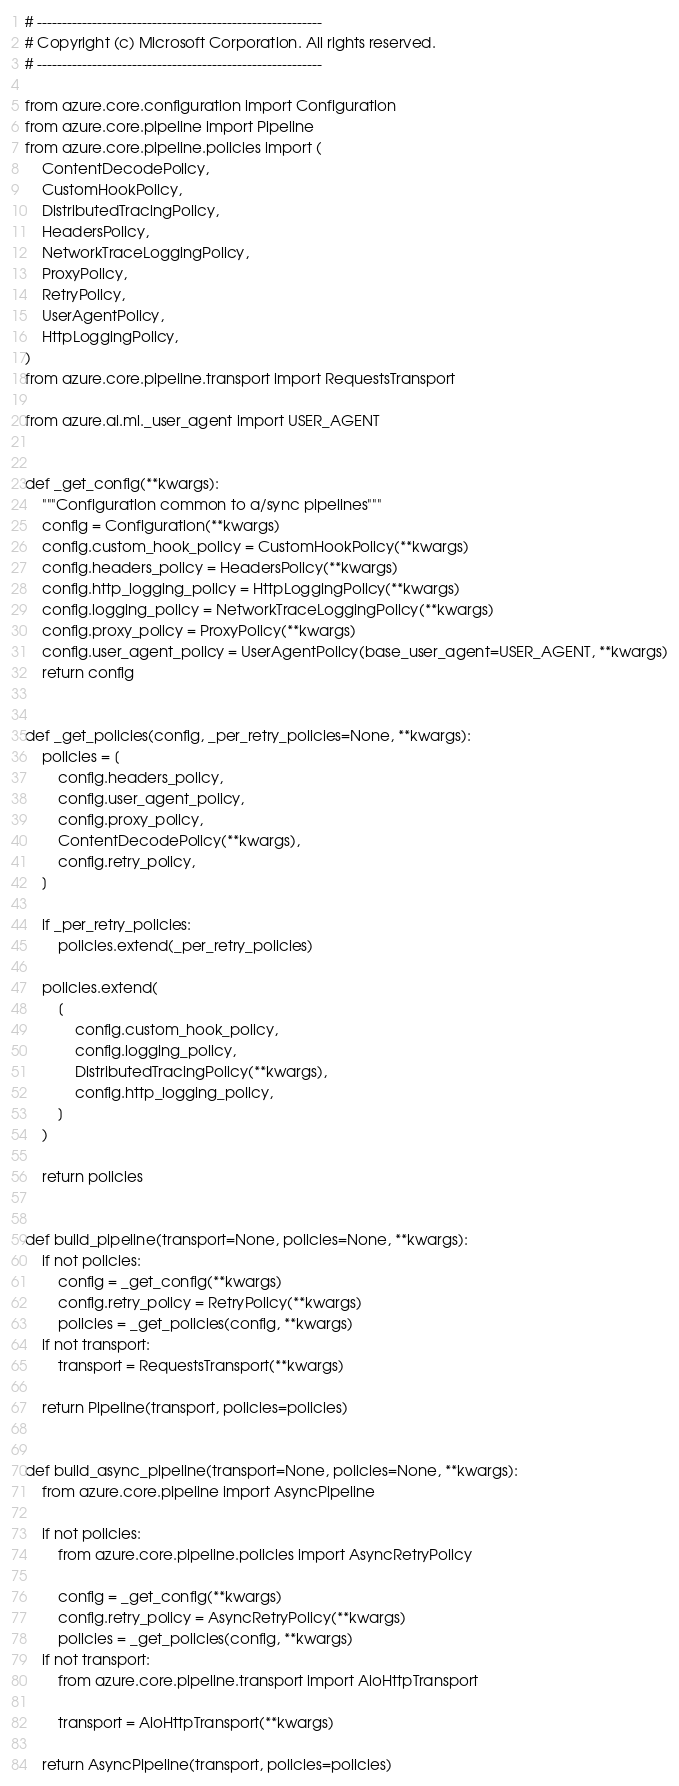<code> <loc_0><loc_0><loc_500><loc_500><_Python_># ---------------------------------------------------------
# Copyright (c) Microsoft Corporation. All rights reserved.
# ---------------------------------------------------------

from azure.core.configuration import Configuration
from azure.core.pipeline import Pipeline
from azure.core.pipeline.policies import (
    ContentDecodePolicy,
    CustomHookPolicy,
    DistributedTracingPolicy,
    HeadersPolicy,
    NetworkTraceLoggingPolicy,
    ProxyPolicy,
    RetryPolicy,
    UserAgentPolicy,
    HttpLoggingPolicy,
)
from azure.core.pipeline.transport import RequestsTransport

from azure.ai.ml._user_agent import USER_AGENT


def _get_config(**kwargs):
    """Configuration common to a/sync pipelines"""
    config = Configuration(**kwargs)
    config.custom_hook_policy = CustomHookPolicy(**kwargs)
    config.headers_policy = HeadersPolicy(**kwargs)
    config.http_logging_policy = HttpLoggingPolicy(**kwargs)
    config.logging_policy = NetworkTraceLoggingPolicy(**kwargs)
    config.proxy_policy = ProxyPolicy(**kwargs)
    config.user_agent_policy = UserAgentPolicy(base_user_agent=USER_AGENT, **kwargs)
    return config


def _get_policies(config, _per_retry_policies=None, **kwargs):
    policies = [
        config.headers_policy,
        config.user_agent_policy,
        config.proxy_policy,
        ContentDecodePolicy(**kwargs),
        config.retry_policy,
    ]

    if _per_retry_policies:
        policies.extend(_per_retry_policies)

    policies.extend(
        [
            config.custom_hook_policy,
            config.logging_policy,
            DistributedTracingPolicy(**kwargs),
            config.http_logging_policy,
        ]
    )

    return policies


def build_pipeline(transport=None, policies=None, **kwargs):
    if not policies:
        config = _get_config(**kwargs)
        config.retry_policy = RetryPolicy(**kwargs)
        policies = _get_policies(config, **kwargs)
    if not transport:
        transport = RequestsTransport(**kwargs)

    return Pipeline(transport, policies=policies)


def build_async_pipeline(transport=None, policies=None, **kwargs):
    from azure.core.pipeline import AsyncPipeline

    if not policies:
        from azure.core.pipeline.policies import AsyncRetryPolicy

        config = _get_config(**kwargs)
        config.retry_policy = AsyncRetryPolicy(**kwargs)
        policies = _get_policies(config, **kwargs)
    if not transport:
        from azure.core.pipeline.transport import AioHttpTransport

        transport = AioHttpTransport(**kwargs)

    return AsyncPipeline(transport, policies=policies)
</code> 